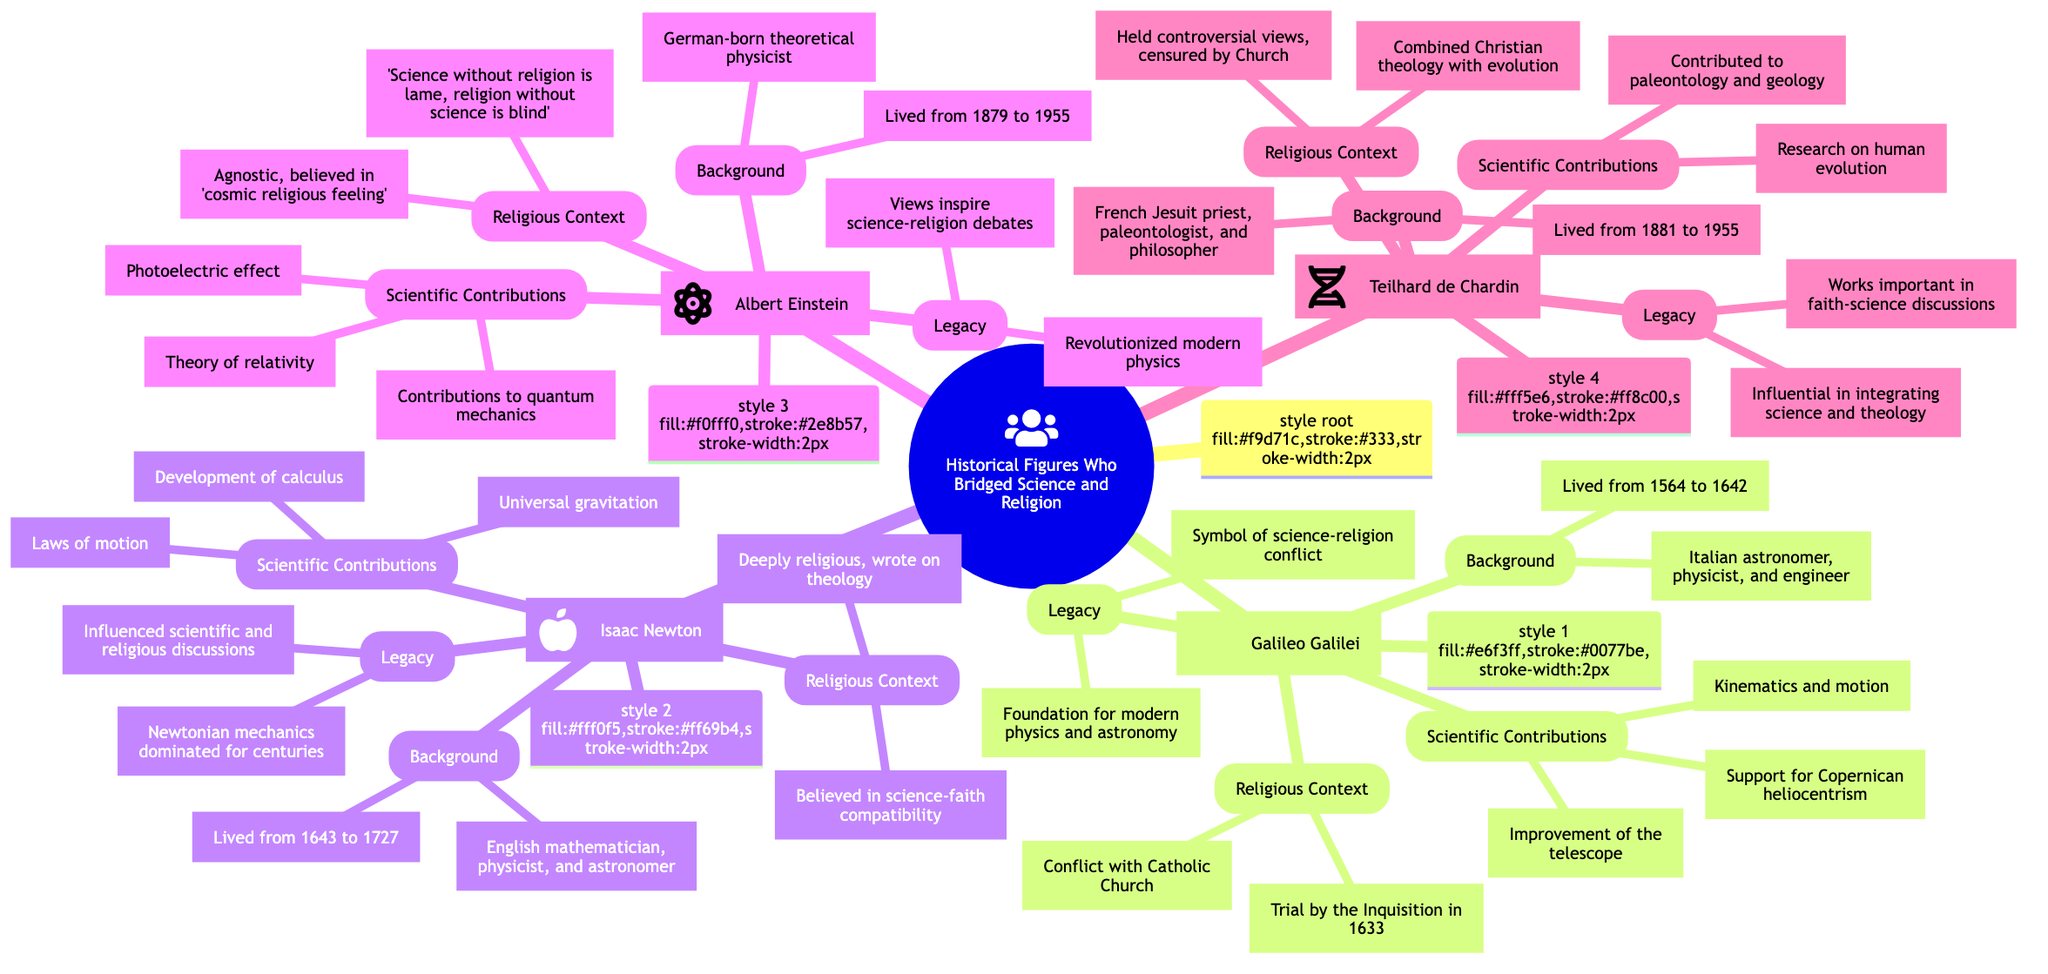What is the time period during which Galileo Galilei lived? The diagram states that Galileo Galilei lived from 1564 to 1642. This is found in the background section of his node.
Answer: 1564 to 1642 How many historical figures are included in the mind map? The mind map has four nodes representing historical figures: Galileo Galilei, Isaac Newton, Albert Einstein, and Teilhard de Chardin. By counting these nodes, we determine the total.
Answer: 4 What scientific contribution is associated with Albert Einstein? In the scientific contributions section of Einstein's node, it lists the theory of relativity as one of his key contributions. This is a direct reference from the diagram.
Answer: Theory of relativity Which historical figure is noted for his conflict with the Catholic Church? According to the religious context of Galileo Galilei's node, it is explicitly stated that he had a conflict with the Catholic Church, leading to significant historical implications.
Answer: Galileo Galilei What is Teilhard de Chardin known for in terms of scientific contributions? The diagram highlights that Teilhard de Chardin conducted research on human evolution, which is found in the scientific contributions section of his node, showcasing his input to science.
Answer: Research on human evolution Which figure believed in the compatibility of faith and science? The religious context of Isaac Newton's node mentions his belief in the compatibility of his scientific discoveries with his faith, indicating a bridge between the two spheres.
Answer: Isaac Newton What legacy is attributed to Albert Einstein? Under the legacy section for Einstein, it states that his views on science and religion continue to inspire debates, which reflects his lasting impact on these fields.
Answer: Views inspire debates How did Galileo Galilei's legacy symbolize a conflict? The legacy section of Galileo's node mentions that he became a symbol of the conflict between science and religious authority, indicating his pivotal role in this historical narrative.
Answer: Symbol of conflict What kind of personal belief did Albert Einstein identify with? The religious context of Einstein's node indicates that he was agnostic and believed in a 'cosmic religious feeling', which portrays his unique stance on spirituality.
Answer: Agnostic, 'cosmic religious feeling' 